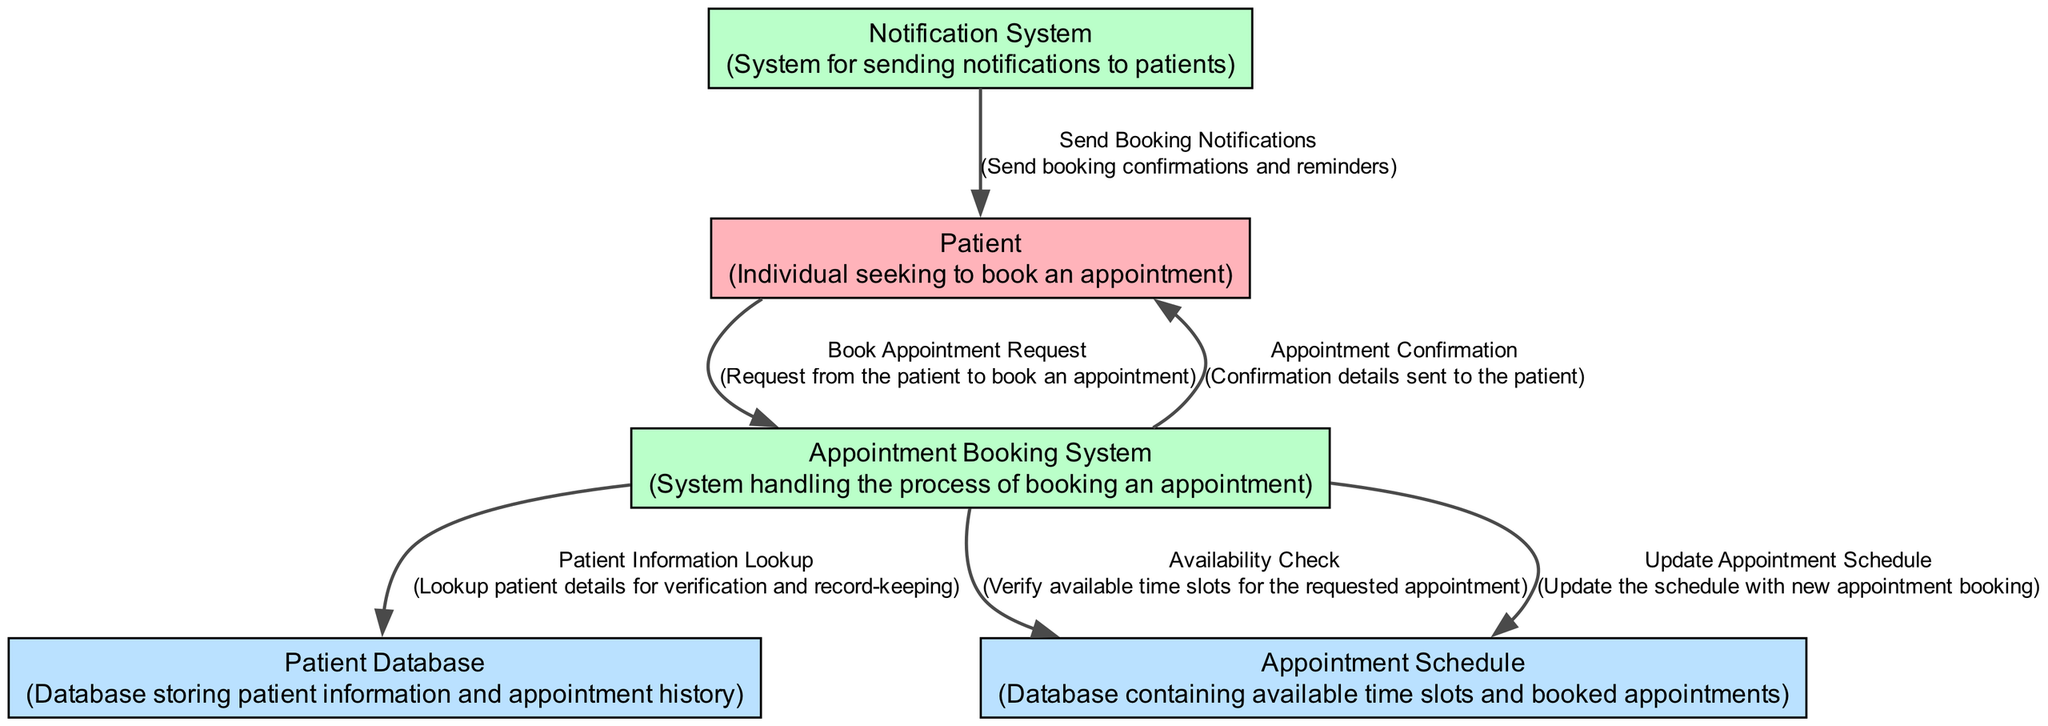What is the source of the "Book Appointment Request"? The "Book Appointment Request" data flow originates from the "Patient" external entity, indicating that it is the input provided by a patient seeking to book an appointment.
Answer: Patient How many data stores are in the diagram? The diagram contains two data stores: "Patient Database" and "Appointment Schedule," which are used to store patient information and manage available appointments, respectively.
Answer: 2 What is the purpose of the "Appointment Booking System"? The "Appointment Booking System" is responsible for managing the booking process of appointments, handling requests, checking availability, and confirming appointments for patients.
Answer: System handling the process of booking an appointment Which process sends the "Send Booking Notifications"? The "Notification System" is the process responsible for sending notifications, including booking confirmations and reminders, to patients after an appointment is booked or updated.
Answer: Notification System What type of data flow is "Availability Check"? "Availability Check" is a data flow that serves the purpose of verifying available time slots for requested appointments, indicating it is a request for information from the booking system to the appointment schedule data store.
Answer: Request for information How does the "Appointment Booking System" interact with the "Patient Database"? The "Appointment Booking System" interacts with the "Patient Database" by performing a "Patient Information Lookup," which involves verifying patient details for appointment booking and record-keeping purposes.
Answer: Performs a "Patient Information Lookup" What action occurs after the "Update Appointment Schedule"? After the "Update Appointment Schedule" data flow updates the appointment schedule, it indicates that a new appointment has been successfully booked, and this directly follows the booking process in the "Appointment Booking System."
Answer: New appointment has been successfully booked What are the two main roles of the "Patient" in the system? The "Patient" plays two main roles: first, they initiate the "Book Appointment Request," and second, they receive the "Appointment Confirmation" after the booking process is completed.
Answer: Initiates appointment booking and receives confirmations 